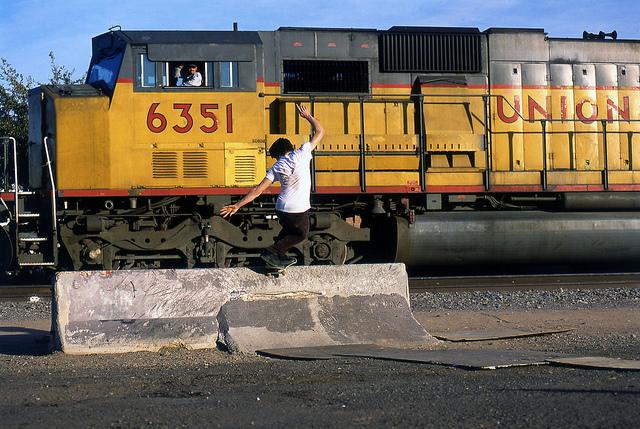What sport is the man doing?
Give a very brief answer. Skateboarding. Is the man wearing safety gear?
Concise answer only. No. What number is written on the train?
Give a very brief answer. 6351. 